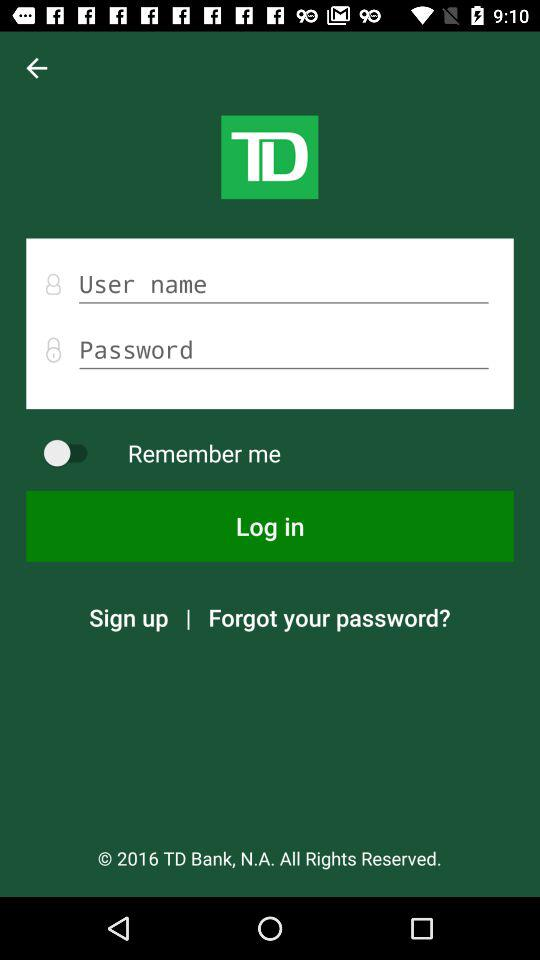What is the application name? The application name is "TD". 